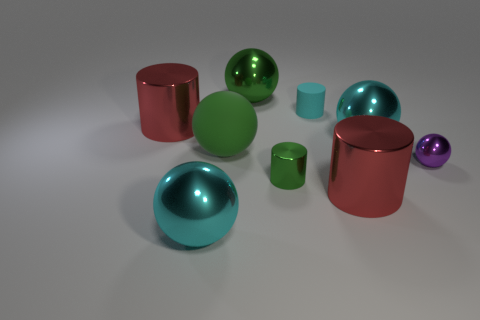Subtract all yellow spheres. Subtract all brown blocks. How many spheres are left? 5 Subtract all yellow cylinders. How many gray balls are left? 0 Add 3 tiny greens. How many objects exist? 0 Subtract all tiny cylinders. Subtract all large metal things. How many objects are left? 2 Add 4 large metal cylinders. How many large metal cylinders are left? 6 Add 8 brown shiny cylinders. How many brown shiny cylinders exist? 8 Add 1 big red things. How many objects exist? 10 Subtract all cyan cylinders. How many cylinders are left? 3 Subtract all metallic balls. How many balls are left? 1 Subtract 0 yellow cubes. How many objects are left? 9 